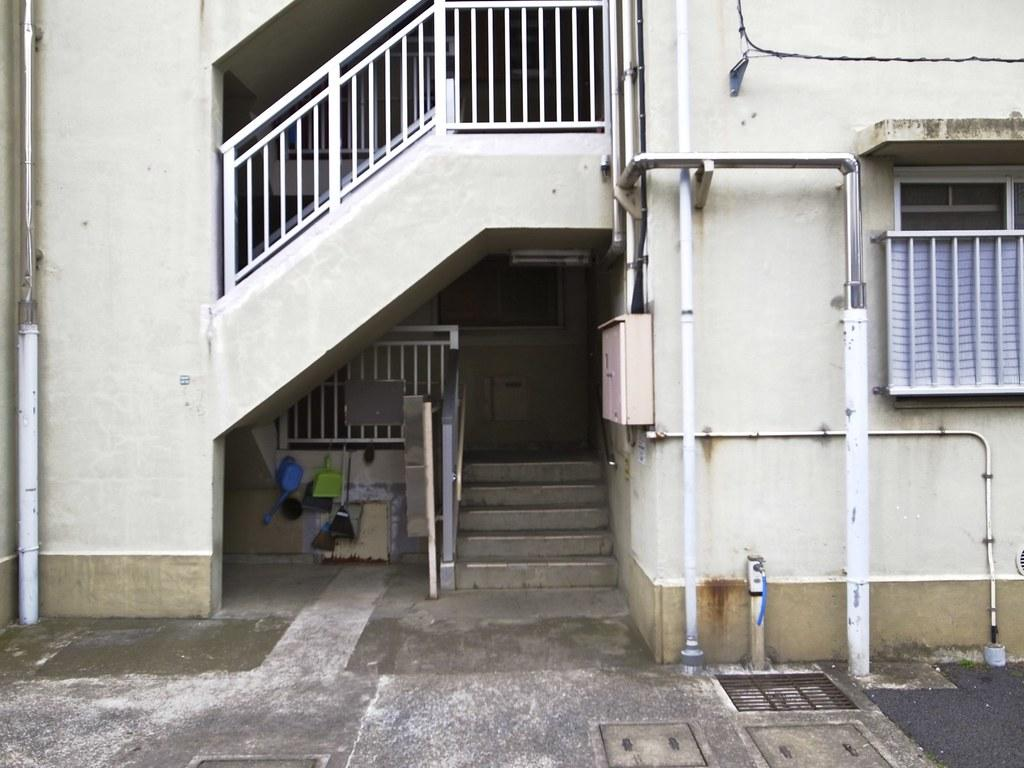What is the main structure in the center of the image? There is a building in the center of the image. Are there any architectural features associated with the building? Yes, there are stairs associated with the building. What is visible at the bottom of the image? There is a road at the bottom of the image. What can be seen on both sides of the image? There are pipes on both the right and left sides of the image. What type of soup is being served in the building in the image? There is no soup or indication of food in the image; it features a building with stairs and pipes. Can you tell me the credit score of the person standing near the building in the image? There is no person or information about credit scores in the image. 